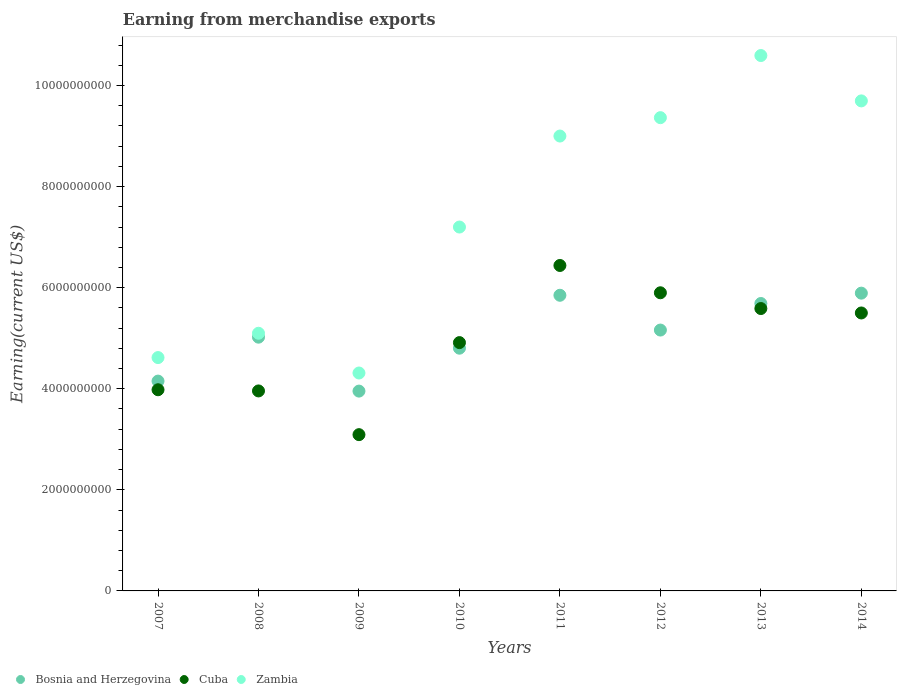What is the amount earned from merchandise exports in Bosnia and Herzegovina in 2009?
Your answer should be compact. 3.95e+09. Across all years, what is the maximum amount earned from merchandise exports in Cuba?
Keep it short and to the point. 6.44e+09. Across all years, what is the minimum amount earned from merchandise exports in Bosnia and Herzegovina?
Offer a very short reply. 3.95e+09. In which year was the amount earned from merchandise exports in Bosnia and Herzegovina minimum?
Give a very brief answer. 2009. What is the total amount earned from merchandise exports in Cuba in the graph?
Give a very brief answer. 3.94e+1. What is the difference between the amount earned from merchandise exports in Bosnia and Herzegovina in 2010 and that in 2012?
Offer a very short reply. -3.59e+08. What is the difference between the amount earned from merchandise exports in Bosnia and Herzegovina in 2013 and the amount earned from merchandise exports in Zambia in 2014?
Your response must be concise. -4.01e+09. What is the average amount earned from merchandise exports in Cuba per year?
Your response must be concise. 4.92e+09. In the year 2007, what is the difference between the amount earned from merchandise exports in Zambia and amount earned from merchandise exports in Bosnia and Herzegovina?
Your answer should be compact. 4.65e+08. What is the ratio of the amount earned from merchandise exports in Zambia in 2011 to that in 2013?
Provide a succinct answer. 0.85. Is the amount earned from merchandise exports in Zambia in 2008 less than that in 2010?
Provide a short and direct response. Yes. What is the difference between the highest and the second highest amount earned from merchandise exports in Bosnia and Herzegovina?
Provide a succinct answer. 4.20e+07. What is the difference between the highest and the lowest amount earned from merchandise exports in Cuba?
Offer a terse response. 3.35e+09. In how many years, is the amount earned from merchandise exports in Zambia greater than the average amount earned from merchandise exports in Zambia taken over all years?
Your answer should be very brief. 4. Is it the case that in every year, the sum of the amount earned from merchandise exports in Cuba and amount earned from merchandise exports in Zambia  is greater than the amount earned from merchandise exports in Bosnia and Herzegovina?
Your answer should be very brief. Yes. Does the amount earned from merchandise exports in Bosnia and Herzegovina monotonically increase over the years?
Your answer should be compact. No. How many years are there in the graph?
Make the answer very short. 8. What is the difference between two consecutive major ticks on the Y-axis?
Make the answer very short. 2.00e+09. Are the values on the major ticks of Y-axis written in scientific E-notation?
Keep it short and to the point. No. Does the graph contain any zero values?
Offer a terse response. No. How many legend labels are there?
Offer a very short reply. 3. What is the title of the graph?
Provide a succinct answer. Earning from merchandise exports. Does "Kiribati" appear as one of the legend labels in the graph?
Provide a short and direct response. No. What is the label or title of the Y-axis?
Offer a terse response. Earning(current US$). What is the Earning(current US$) in Bosnia and Herzegovina in 2007?
Offer a terse response. 4.15e+09. What is the Earning(current US$) of Cuba in 2007?
Your response must be concise. 3.98e+09. What is the Earning(current US$) in Zambia in 2007?
Offer a terse response. 4.62e+09. What is the Earning(current US$) of Bosnia and Herzegovina in 2008?
Offer a very short reply. 5.02e+09. What is the Earning(current US$) in Cuba in 2008?
Offer a terse response. 3.96e+09. What is the Earning(current US$) in Zambia in 2008?
Make the answer very short. 5.10e+09. What is the Earning(current US$) of Bosnia and Herzegovina in 2009?
Offer a terse response. 3.95e+09. What is the Earning(current US$) of Cuba in 2009?
Offer a terse response. 3.09e+09. What is the Earning(current US$) of Zambia in 2009?
Offer a terse response. 4.31e+09. What is the Earning(current US$) of Bosnia and Herzegovina in 2010?
Provide a short and direct response. 4.80e+09. What is the Earning(current US$) of Cuba in 2010?
Provide a succinct answer. 4.91e+09. What is the Earning(current US$) of Zambia in 2010?
Your answer should be compact. 7.20e+09. What is the Earning(current US$) in Bosnia and Herzegovina in 2011?
Provide a succinct answer. 5.85e+09. What is the Earning(current US$) in Cuba in 2011?
Ensure brevity in your answer.  6.44e+09. What is the Earning(current US$) in Zambia in 2011?
Provide a short and direct response. 9.00e+09. What is the Earning(current US$) in Bosnia and Herzegovina in 2012?
Your answer should be very brief. 5.16e+09. What is the Earning(current US$) in Cuba in 2012?
Provide a succinct answer. 5.90e+09. What is the Earning(current US$) in Zambia in 2012?
Provide a succinct answer. 9.36e+09. What is the Earning(current US$) of Bosnia and Herzegovina in 2013?
Offer a very short reply. 5.69e+09. What is the Earning(current US$) of Cuba in 2013?
Offer a very short reply. 5.59e+09. What is the Earning(current US$) of Zambia in 2013?
Keep it short and to the point. 1.06e+1. What is the Earning(current US$) in Bosnia and Herzegovina in 2014?
Give a very brief answer. 5.89e+09. What is the Earning(current US$) of Cuba in 2014?
Keep it short and to the point. 5.50e+09. What is the Earning(current US$) in Zambia in 2014?
Your answer should be very brief. 9.70e+09. Across all years, what is the maximum Earning(current US$) in Bosnia and Herzegovina?
Provide a succinct answer. 5.89e+09. Across all years, what is the maximum Earning(current US$) in Cuba?
Provide a succinct answer. 6.44e+09. Across all years, what is the maximum Earning(current US$) of Zambia?
Your response must be concise. 1.06e+1. Across all years, what is the minimum Earning(current US$) of Bosnia and Herzegovina?
Offer a very short reply. 3.95e+09. Across all years, what is the minimum Earning(current US$) in Cuba?
Make the answer very short. 3.09e+09. Across all years, what is the minimum Earning(current US$) of Zambia?
Offer a very short reply. 4.31e+09. What is the total Earning(current US$) in Bosnia and Herzegovina in the graph?
Your answer should be very brief. 4.05e+1. What is the total Earning(current US$) in Cuba in the graph?
Make the answer very short. 3.94e+1. What is the total Earning(current US$) of Zambia in the graph?
Make the answer very short. 5.99e+1. What is the difference between the Earning(current US$) in Bosnia and Herzegovina in 2007 and that in 2008?
Your response must be concise. -8.69e+08. What is the difference between the Earning(current US$) in Cuba in 2007 and that in 2008?
Offer a terse response. 2.32e+07. What is the difference between the Earning(current US$) in Zambia in 2007 and that in 2008?
Give a very brief answer. -4.81e+08. What is the difference between the Earning(current US$) of Bosnia and Herzegovina in 2007 and that in 2009?
Give a very brief answer. 1.98e+08. What is the difference between the Earning(current US$) in Cuba in 2007 and that in 2009?
Keep it short and to the point. 8.89e+08. What is the difference between the Earning(current US$) of Zambia in 2007 and that in 2009?
Offer a very short reply. 3.05e+08. What is the difference between the Earning(current US$) of Bosnia and Herzegovina in 2007 and that in 2010?
Your response must be concise. -6.51e+08. What is the difference between the Earning(current US$) of Cuba in 2007 and that in 2010?
Offer a very short reply. -9.33e+08. What is the difference between the Earning(current US$) in Zambia in 2007 and that in 2010?
Make the answer very short. -2.58e+09. What is the difference between the Earning(current US$) of Bosnia and Herzegovina in 2007 and that in 2011?
Your answer should be very brief. -1.70e+09. What is the difference between the Earning(current US$) in Cuba in 2007 and that in 2011?
Ensure brevity in your answer.  -2.46e+09. What is the difference between the Earning(current US$) of Zambia in 2007 and that in 2011?
Ensure brevity in your answer.  -4.38e+09. What is the difference between the Earning(current US$) of Bosnia and Herzegovina in 2007 and that in 2012?
Give a very brief answer. -1.01e+09. What is the difference between the Earning(current US$) of Cuba in 2007 and that in 2012?
Your response must be concise. -1.92e+09. What is the difference between the Earning(current US$) in Zambia in 2007 and that in 2012?
Give a very brief answer. -4.75e+09. What is the difference between the Earning(current US$) of Bosnia and Herzegovina in 2007 and that in 2013?
Provide a succinct answer. -1.54e+09. What is the difference between the Earning(current US$) of Cuba in 2007 and that in 2013?
Your answer should be compact. -1.61e+09. What is the difference between the Earning(current US$) in Zambia in 2007 and that in 2013?
Ensure brevity in your answer.  -5.98e+09. What is the difference between the Earning(current US$) of Bosnia and Herzegovina in 2007 and that in 2014?
Your answer should be very brief. -1.74e+09. What is the difference between the Earning(current US$) of Cuba in 2007 and that in 2014?
Give a very brief answer. -1.52e+09. What is the difference between the Earning(current US$) of Zambia in 2007 and that in 2014?
Ensure brevity in your answer.  -5.08e+09. What is the difference between the Earning(current US$) of Bosnia and Herzegovina in 2008 and that in 2009?
Make the answer very short. 1.07e+09. What is the difference between the Earning(current US$) in Cuba in 2008 and that in 2009?
Make the answer very short. 8.65e+08. What is the difference between the Earning(current US$) in Zambia in 2008 and that in 2009?
Ensure brevity in your answer.  7.87e+08. What is the difference between the Earning(current US$) of Bosnia and Herzegovina in 2008 and that in 2010?
Offer a terse response. 2.18e+08. What is the difference between the Earning(current US$) in Cuba in 2008 and that in 2010?
Provide a short and direct response. -9.56e+08. What is the difference between the Earning(current US$) in Zambia in 2008 and that in 2010?
Your answer should be compact. -2.10e+09. What is the difference between the Earning(current US$) in Bosnia and Herzegovina in 2008 and that in 2011?
Make the answer very short. -8.29e+08. What is the difference between the Earning(current US$) of Cuba in 2008 and that in 2011?
Your response must be concise. -2.48e+09. What is the difference between the Earning(current US$) of Zambia in 2008 and that in 2011?
Ensure brevity in your answer.  -3.90e+09. What is the difference between the Earning(current US$) of Bosnia and Herzegovina in 2008 and that in 2012?
Ensure brevity in your answer.  -1.41e+08. What is the difference between the Earning(current US$) in Cuba in 2008 and that in 2012?
Provide a succinct answer. -1.94e+09. What is the difference between the Earning(current US$) in Zambia in 2008 and that in 2012?
Provide a short and direct response. -4.27e+09. What is the difference between the Earning(current US$) in Bosnia and Herzegovina in 2008 and that in 2013?
Offer a terse response. -6.66e+08. What is the difference between the Earning(current US$) of Cuba in 2008 and that in 2013?
Make the answer very short. -1.63e+09. What is the difference between the Earning(current US$) of Zambia in 2008 and that in 2013?
Your answer should be compact. -5.50e+09. What is the difference between the Earning(current US$) in Bosnia and Herzegovina in 2008 and that in 2014?
Your answer should be compact. -8.71e+08. What is the difference between the Earning(current US$) of Cuba in 2008 and that in 2014?
Your answer should be compact. -1.54e+09. What is the difference between the Earning(current US$) in Zambia in 2008 and that in 2014?
Offer a very short reply. -4.60e+09. What is the difference between the Earning(current US$) in Bosnia and Herzegovina in 2009 and that in 2010?
Offer a terse response. -8.49e+08. What is the difference between the Earning(current US$) in Cuba in 2009 and that in 2010?
Provide a short and direct response. -1.82e+09. What is the difference between the Earning(current US$) of Zambia in 2009 and that in 2010?
Ensure brevity in your answer.  -2.89e+09. What is the difference between the Earning(current US$) of Bosnia and Herzegovina in 2009 and that in 2011?
Provide a short and direct response. -1.90e+09. What is the difference between the Earning(current US$) in Cuba in 2009 and that in 2011?
Provide a succinct answer. -3.35e+09. What is the difference between the Earning(current US$) in Zambia in 2009 and that in 2011?
Offer a terse response. -4.69e+09. What is the difference between the Earning(current US$) of Bosnia and Herzegovina in 2009 and that in 2012?
Make the answer very short. -1.21e+09. What is the difference between the Earning(current US$) in Cuba in 2009 and that in 2012?
Your response must be concise. -2.81e+09. What is the difference between the Earning(current US$) of Zambia in 2009 and that in 2012?
Give a very brief answer. -5.05e+09. What is the difference between the Earning(current US$) in Bosnia and Herzegovina in 2009 and that in 2013?
Ensure brevity in your answer.  -1.73e+09. What is the difference between the Earning(current US$) in Cuba in 2009 and that in 2013?
Your answer should be compact. -2.50e+09. What is the difference between the Earning(current US$) of Zambia in 2009 and that in 2013?
Provide a succinct answer. -6.28e+09. What is the difference between the Earning(current US$) in Bosnia and Herzegovina in 2009 and that in 2014?
Offer a terse response. -1.94e+09. What is the difference between the Earning(current US$) of Cuba in 2009 and that in 2014?
Your response must be concise. -2.41e+09. What is the difference between the Earning(current US$) of Zambia in 2009 and that in 2014?
Offer a very short reply. -5.38e+09. What is the difference between the Earning(current US$) of Bosnia and Herzegovina in 2010 and that in 2011?
Your answer should be very brief. -1.05e+09. What is the difference between the Earning(current US$) in Cuba in 2010 and that in 2011?
Offer a terse response. -1.53e+09. What is the difference between the Earning(current US$) of Zambia in 2010 and that in 2011?
Make the answer very short. -1.80e+09. What is the difference between the Earning(current US$) in Bosnia and Herzegovina in 2010 and that in 2012?
Make the answer very short. -3.59e+08. What is the difference between the Earning(current US$) in Cuba in 2010 and that in 2012?
Your answer should be very brief. -9.86e+08. What is the difference between the Earning(current US$) of Zambia in 2010 and that in 2012?
Your answer should be very brief. -2.16e+09. What is the difference between the Earning(current US$) in Bosnia and Herzegovina in 2010 and that in 2013?
Keep it short and to the point. -8.84e+08. What is the difference between the Earning(current US$) in Cuba in 2010 and that in 2013?
Keep it short and to the point. -6.74e+08. What is the difference between the Earning(current US$) in Zambia in 2010 and that in 2013?
Your answer should be compact. -3.39e+09. What is the difference between the Earning(current US$) of Bosnia and Herzegovina in 2010 and that in 2014?
Give a very brief answer. -1.09e+09. What is the difference between the Earning(current US$) of Cuba in 2010 and that in 2014?
Provide a short and direct response. -5.86e+08. What is the difference between the Earning(current US$) in Zambia in 2010 and that in 2014?
Your response must be concise. -2.50e+09. What is the difference between the Earning(current US$) in Bosnia and Herzegovina in 2011 and that in 2012?
Make the answer very short. 6.88e+08. What is the difference between the Earning(current US$) of Cuba in 2011 and that in 2012?
Offer a very short reply. 5.40e+08. What is the difference between the Earning(current US$) of Zambia in 2011 and that in 2012?
Provide a succinct answer. -3.64e+08. What is the difference between the Earning(current US$) of Bosnia and Herzegovina in 2011 and that in 2013?
Give a very brief answer. 1.63e+08. What is the difference between the Earning(current US$) in Cuba in 2011 and that in 2013?
Offer a terse response. 8.52e+08. What is the difference between the Earning(current US$) in Zambia in 2011 and that in 2013?
Provide a succinct answer. -1.59e+09. What is the difference between the Earning(current US$) in Bosnia and Herzegovina in 2011 and that in 2014?
Provide a succinct answer. -4.20e+07. What is the difference between the Earning(current US$) in Cuba in 2011 and that in 2014?
Provide a succinct answer. 9.40e+08. What is the difference between the Earning(current US$) in Zambia in 2011 and that in 2014?
Your response must be concise. -6.95e+08. What is the difference between the Earning(current US$) in Bosnia and Herzegovina in 2012 and that in 2013?
Make the answer very short. -5.26e+08. What is the difference between the Earning(current US$) in Cuba in 2012 and that in 2013?
Offer a very short reply. 3.12e+08. What is the difference between the Earning(current US$) of Zambia in 2012 and that in 2013?
Ensure brevity in your answer.  -1.23e+09. What is the difference between the Earning(current US$) in Bosnia and Herzegovina in 2012 and that in 2014?
Your response must be concise. -7.30e+08. What is the difference between the Earning(current US$) in Cuba in 2012 and that in 2014?
Offer a very short reply. 4.00e+08. What is the difference between the Earning(current US$) in Zambia in 2012 and that in 2014?
Give a very brief answer. -3.32e+08. What is the difference between the Earning(current US$) in Bosnia and Herzegovina in 2013 and that in 2014?
Keep it short and to the point. -2.05e+08. What is the difference between the Earning(current US$) in Cuba in 2013 and that in 2014?
Keep it short and to the point. 8.77e+07. What is the difference between the Earning(current US$) of Zambia in 2013 and that in 2014?
Keep it short and to the point. 8.98e+08. What is the difference between the Earning(current US$) in Bosnia and Herzegovina in 2007 and the Earning(current US$) in Cuba in 2008?
Keep it short and to the point. 1.95e+08. What is the difference between the Earning(current US$) in Bosnia and Herzegovina in 2007 and the Earning(current US$) in Zambia in 2008?
Offer a very short reply. -9.47e+08. What is the difference between the Earning(current US$) in Cuba in 2007 and the Earning(current US$) in Zambia in 2008?
Offer a terse response. -1.12e+09. What is the difference between the Earning(current US$) of Bosnia and Herzegovina in 2007 and the Earning(current US$) of Cuba in 2009?
Offer a very short reply. 1.06e+09. What is the difference between the Earning(current US$) in Bosnia and Herzegovina in 2007 and the Earning(current US$) in Zambia in 2009?
Your answer should be compact. -1.60e+08. What is the difference between the Earning(current US$) of Cuba in 2007 and the Earning(current US$) of Zambia in 2009?
Your response must be concise. -3.31e+08. What is the difference between the Earning(current US$) of Bosnia and Herzegovina in 2007 and the Earning(current US$) of Cuba in 2010?
Offer a very short reply. -7.62e+08. What is the difference between the Earning(current US$) of Bosnia and Herzegovina in 2007 and the Earning(current US$) of Zambia in 2010?
Your response must be concise. -3.05e+09. What is the difference between the Earning(current US$) of Cuba in 2007 and the Earning(current US$) of Zambia in 2010?
Provide a short and direct response. -3.22e+09. What is the difference between the Earning(current US$) of Bosnia and Herzegovina in 2007 and the Earning(current US$) of Cuba in 2011?
Your answer should be very brief. -2.29e+09. What is the difference between the Earning(current US$) of Bosnia and Herzegovina in 2007 and the Earning(current US$) of Zambia in 2011?
Provide a short and direct response. -4.85e+09. What is the difference between the Earning(current US$) in Cuba in 2007 and the Earning(current US$) in Zambia in 2011?
Your answer should be compact. -5.02e+09. What is the difference between the Earning(current US$) of Bosnia and Herzegovina in 2007 and the Earning(current US$) of Cuba in 2012?
Keep it short and to the point. -1.75e+09. What is the difference between the Earning(current US$) of Bosnia and Herzegovina in 2007 and the Earning(current US$) of Zambia in 2012?
Keep it short and to the point. -5.21e+09. What is the difference between the Earning(current US$) in Cuba in 2007 and the Earning(current US$) in Zambia in 2012?
Your answer should be very brief. -5.38e+09. What is the difference between the Earning(current US$) of Bosnia and Herzegovina in 2007 and the Earning(current US$) of Cuba in 2013?
Provide a succinct answer. -1.44e+09. What is the difference between the Earning(current US$) of Bosnia and Herzegovina in 2007 and the Earning(current US$) of Zambia in 2013?
Offer a very short reply. -6.44e+09. What is the difference between the Earning(current US$) in Cuba in 2007 and the Earning(current US$) in Zambia in 2013?
Make the answer very short. -6.61e+09. What is the difference between the Earning(current US$) in Bosnia and Herzegovina in 2007 and the Earning(current US$) in Cuba in 2014?
Your answer should be very brief. -1.35e+09. What is the difference between the Earning(current US$) of Bosnia and Herzegovina in 2007 and the Earning(current US$) of Zambia in 2014?
Your answer should be very brief. -5.54e+09. What is the difference between the Earning(current US$) in Cuba in 2007 and the Earning(current US$) in Zambia in 2014?
Make the answer very short. -5.72e+09. What is the difference between the Earning(current US$) of Bosnia and Herzegovina in 2008 and the Earning(current US$) of Cuba in 2009?
Give a very brief answer. 1.93e+09. What is the difference between the Earning(current US$) in Bosnia and Herzegovina in 2008 and the Earning(current US$) in Zambia in 2009?
Offer a very short reply. 7.09e+08. What is the difference between the Earning(current US$) of Cuba in 2008 and the Earning(current US$) of Zambia in 2009?
Your answer should be very brief. -3.55e+08. What is the difference between the Earning(current US$) of Bosnia and Herzegovina in 2008 and the Earning(current US$) of Cuba in 2010?
Provide a short and direct response. 1.07e+08. What is the difference between the Earning(current US$) in Bosnia and Herzegovina in 2008 and the Earning(current US$) in Zambia in 2010?
Keep it short and to the point. -2.18e+09. What is the difference between the Earning(current US$) of Cuba in 2008 and the Earning(current US$) of Zambia in 2010?
Give a very brief answer. -3.24e+09. What is the difference between the Earning(current US$) of Bosnia and Herzegovina in 2008 and the Earning(current US$) of Cuba in 2011?
Make the answer very short. -1.42e+09. What is the difference between the Earning(current US$) in Bosnia and Herzegovina in 2008 and the Earning(current US$) in Zambia in 2011?
Your answer should be compact. -3.98e+09. What is the difference between the Earning(current US$) in Cuba in 2008 and the Earning(current US$) in Zambia in 2011?
Your answer should be compact. -5.04e+09. What is the difference between the Earning(current US$) of Bosnia and Herzegovina in 2008 and the Earning(current US$) of Cuba in 2012?
Your response must be concise. -8.78e+08. What is the difference between the Earning(current US$) in Bosnia and Herzegovina in 2008 and the Earning(current US$) in Zambia in 2012?
Give a very brief answer. -4.34e+09. What is the difference between the Earning(current US$) in Cuba in 2008 and the Earning(current US$) in Zambia in 2012?
Provide a succinct answer. -5.41e+09. What is the difference between the Earning(current US$) in Bosnia and Herzegovina in 2008 and the Earning(current US$) in Cuba in 2013?
Your answer should be compact. -5.67e+08. What is the difference between the Earning(current US$) of Bosnia and Herzegovina in 2008 and the Earning(current US$) of Zambia in 2013?
Your answer should be very brief. -5.57e+09. What is the difference between the Earning(current US$) in Cuba in 2008 and the Earning(current US$) in Zambia in 2013?
Your response must be concise. -6.64e+09. What is the difference between the Earning(current US$) of Bosnia and Herzegovina in 2008 and the Earning(current US$) of Cuba in 2014?
Your answer should be compact. -4.79e+08. What is the difference between the Earning(current US$) of Bosnia and Herzegovina in 2008 and the Earning(current US$) of Zambia in 2014?
Give a very brief answer. -4.68e+09. What is the difference between the Earning(current US$) of Cuba in 2008 and the Earning(current US$) of Zambia in 2014?
Offer a very short reply. -5.74e+09. What is the difference between the Earning(current US$) of Bosnia and Herzegovina in 2009 and the Earning(current US$) of Cuba in 2010?
Provide a succinct answer. -9.60e+08. What is the difference between the Earning(current US$) of Bosnia and Herzegovina in 2009 and the Earning(current US$) of Zambia in 2010?
Your answer should be compact. -3.25e+09. What is the difference between the Earning(current US$) in Cuba in 2009 and the Earning(current US$) in Zambia in 2010?
Your response must be concise. -4.11e+09. What is the difference between the Earning(current US$) in Bosnia and Herzegovina in 2009 and the Earning(current US$) in Cuba in 2011?
Ensure brevity in your answer.  -2.49e+09. What is the difference between the Earning(current US$) of Bosnia and Herzegovina in 2009 and the Earning(current US$) of Zambia in 2011?
Your response must be concise. -5.05e+09. What is the difference between the Earning(current US$) of Cuba in 2009 and the Earning(current US$) of Zambia in 2011?
Your answer should be very brief. -5.91e+09. What is the difference between the Earning(current US$) of Bosnia and Herzegovina in 2009 and the Earning(current US$) of Cuba in 2012?
Your response must be concise. -1.95e+09. What is the difference between the Earning(current US$) in Bosnia and Herzegovina in 2009 and the Earning(current US$) in Zambia in 2012?
Your response must be concise. -5.41e+09. What is the difference between the Earning(current US$) in Cuba in 2009 and the Earning(current US$) in Zambia in 2012?
Your response must be concise. -6.27e+09. What is the difference between the Earning(current US$) of Bosnia and Herzegovina in 2009 and the Earning(current US$) of Cuba in 2013?
Your answer should be very brief. -1.63e+09. What is the difference between the Earning(current US$) in Bosnia and Herzegovina in 2009 and the Earning(current US$) in Zambia in 2013?
Your answer should be very brief. -6.64e+09. What is the difference between the Earning(current US$) of Cuba in 2009 and the Earning(current US$) of Zambia in 2013?
Ensure brevity in your answer.  -7.50e+09. What is the difference between the Earning(current US$) of Bosnia and Herzegovina in 2009 and the Earning(current US$) of Cuba in 2014?
Provide a succinct answer. -1.55e+09. What is the difference between the Earning(current US$) of Bosnia and Herzegovina in 2009 and the Earning(current US$) of Zambia in 2014?
Offer a terse response. -5.74e+09. What is the difference between the Earning(current US$) of Cuba in 2009 and the Earning(current US$) of Zambia in 2014?
Offer a terse response. -6.60e+09. What is the difference between the Earning(current US$) of Bosnia and Herzegovina in 2010 and the Earning(current US$) of Cuba in 2011?
Offer a very short reply. -1.64e+09. What is the difference between the Earning(current US$) of Bosnia and Herzegovina in 2010 and the Earning(current US$) of Zambia in 2011?
Make the answer very short. -4.20e+09. What is the difference between the Earning(current US$) in Cuba in 2010 and the Earning(current US$) in Zambia in 2011?
Provide a short and direct response. -4.09e+09. What is the difference between the Earning(current US$) in Bosnia and Herzegovina in 2010 and the Earning(current US$) in Cuba in 2012?
Ensure brevity in your answer.  -1.10e+09. What is the difference between the Earning(current US$) of Bosnia and Herzegovina in 2010 and the Earning(current US$) of Zambia in 2012?
Provide a short and direct response. -4.56e+09. What is the difference between the Earning(current US$) of Cuba in 2010 and the Earning(current US$) of Zambia in 2012?
Offer a terse response. -4.45e+09. What is the difference between the Earning(current US$) of Bosnia and Herzegovina in 2010 and the Earning(current US$) of Cuba in 2013?
Ensure brevity in your answer.  -7.85e+08. What is the difference between the Earning(current US$) of Bosnia and Herzegovina in 2010 and the Earning(current US$) of Zambia in 2013?
Keep it short and to the point. -5.79e+09. What is the difference between the Earning(current US$) in Cuba in 2010 and the Earning(current US$) in Zambia in 2013?
Offer a very short reply. -5.68e+09. What is the difference between the Earning(current US$) of Bosnia and Herzegovina in 2010 and the Earning(current US$) of Cuba in 2014?
Your response must be concise. -6.97e+08. What is the difference between the Earning(current US$) in Bosnia and Herzegovina in 2010 and the Earning(current US$) in Zambia in 2014?
Your answer should be very brief. -4.89e+09. What is the difference between the Earning(current US$) in Cuba in 2010 and the Earning(current US$) in Zambia in 2014?
Your response must be concise. -4.78e+09. What is the difference between the Earning(current US$) of Bosnia and Herzegovina in 2011 and the Earning(current US$) of Cuba in 2012?
Make the answer very short. -4.94e+07. What is the difference between the Earning(current US$) in Bosnia and Herzegovina in 2011 and the Earning(current US$) in Zambia in 2012?
Your response must be concise. -3.51e+09. What is the difference between the Earning(current US$) in Cuba in 2011 and the Earning(current US$) in Zambia in 2012?
Offer a very short reply. -2.92e+09. What is the difference between the Earning(current US$) in Bosnia and Herzegovina in 2011 and the Earning(current US$) in Cuba in 2013?
Keep it short and to the point. 2.62e+08. What is the difference between the Earning(current US$) of Bosnia and Herzegovina in 2011 and the Earning(current US$) of Zambia in 2013?
Provide a succinct answer. -4.74e+09. What is the difference between the Earning(current US$) in Cuba in 2011 and the Earning(current US$) in Zambia in 2013?
Your answer should be compact. -4.15e+09. What is the difference between the Earning(current US$) in Bosnia and Herzegovina in 2011 and the Earning(current US$) in Cuba in 2014?
Give a very brief answer. 3.50e+08. What is the difference between the Earning(current US$) of Bosnia and Herzegovina in 2011 and the Earning(current US$) of Zambia in 2014?
Provide a succinct answer. -3.85e+09. What is the difference between the Earning(current US$) of Cuba in 2011 and the Earning(current US$) of Zambia in 2014?
Ensure brevity in your answer.  -3.26e+09. What is the difference between the Earning(current US$) of Bosnia and Herzegovina in 2012 and the Earning(current US$) of Cuba in 2013?
Provide a short and direct response. -4.26e+08. What is the difference between the Earning(current US$) in Bosnia and Herzegovina in 2012 and the Earning(current US$) in Zambia in 2013?
Offer a very short reply. -5.43e+09. What is the difference between the Earning(current US$) of Cuba in 2012 and the Earning(current US$) of Zambia in 2013?
Keep it short and to the point. -4.69e+09. What is the difference between the Earning(current US$) in Bosnia and Herzegovina in 2012 and the Earning(current US$) in Cuba in 2014?
Provide a short and direct response. -3.38e+08. What is the difference between the Earning(current US$) of Bosnia and Herzegovina in 2012 and the Earning(current US$) of Zambia in 2014?
Make the answer very short. -4.53e+09. What is the difference between the Earning(current US$) of Cuba in 2012 and the Earning(current US$) of Zambia in 2014?
Offer a terse response. -3.80e+09. What is the difference between the Earning(current US$) in Bosnia and Herzegovina in 2013 and the Earning(current US$) in Cuba in 2014?
Give a very brief answer. 1.87e+08. What is the difference between the Earning(current US$) of Bosnia and Herzegovina in 2013 and the Earning(current US$) of Zambia in 2014?
Keep it short and to the point. -4.01e+09. What is the difference between the Earning(current US$) in Cuba in 2013 and the Earning(current US$) in Zambia in 2014?
Ensure brevity in your answer.  -4.11e+09. What is the average Earning(current US$) of Bosnia and Herzegovina per year?
Offer a very short reply. 5.07e+09. What is the average Earning(current US$) of Cuba per year?
Your answer should be very brief. 4.92e+09. What is the average Earning(current US$) in Zambia per year?
Your answer should be very brief. 7.49e+09. In the year 2007, what is the difference between the Earning(current US$) in Bosnia and Herzegovina and Earning(current US$) in Cuba?
Ensure brevity in your answer.  1.71e+08. In the year 2007, what is the difference between the Earning(current US$) in Bosnia and Herzegovina and Earning(current US$) in Zambia?
Make the answer very short. -4.65e+08. In the year 2007, what is the difference between the Earning(current US$) of Cuba and Earning(current US$) of Zambia?
Provide a short and direct response. -6.37e+08. In the year 2008, what is the difference between the Earning(current US$) of Bosnia and Herzegovina and Earning(current US$) of Cuba?
Make the answer very short. 1.06e+09. In the year 2008, what is the difference between the Earning(current US$) in Bosnia and Herzegovina and Earning(current US$) in Zambia?
Your response must be concise. -7.76e+07. In the year 2008, what is the difference between the Earning(current US$) of Cuba and Earning(current US$) of Zambia?
Give a very brief answer. -1.14e+09. In the year 2009, what is the difference between the Earning(current US$) in Bosnia and Herzegovina and Earning(current US$) in Cuba?
Ensure brevity in your answer.  8.62e+08. In the year 2009, what is the difference between the Earning(current US$) in Bosnia and Herzegovina and Earning(current US$) in Zambia?
Give a very brief answer. -3.58e+08. In the year 2009, what is the difference between the Earning(current US$) in Cuba and Earning(current US$) in Zambia?
Ensure brevity in your answer.  -1.22e+09. In the year 2010, what is the difference between the Earning(current US$) in Bosnia and Herzegovina and Earning(current US$) in Cuba?
Offer a very short reply. -1.10e+08. In the year 2010, what is the difference between the Earning(current US$) of Bosnia and Herzegovina and Earning(current US$) of Zambia?
Give a very brief answer. -2.40e+09. In the year 2010, what is the difference between the Earning(current US$) of Cuba and Earning(current US$) of Zambia?
Provide a succinct answer. -2.29e+09. In the year 2011, what is the difference between the Earning(current US$) of Bosnia and Herzegovina and Earning(current US$) of Cuba?
Your response must be concise. -5.90e+08. In the year 2011, what is the difference between the Earning(current US$) of Bosnia and Herzegovina and Earning(current US$) of Zambia?
Offer a terse response. -3.15e+09. In the year 2011, what is the difference between the Earning(current US$) of Cuba and Earning(current US$) of Zambia?
Offer a very short reply. -2.56e+09. In the year 2012, what is the difference between the Earning(current US$) of Bosnia and Herzegovina and Earning(current US$) of Cuba?
Your response must be concise. -7.38e+08. In the year 2012, what is the difference between the Earning(current US$) in Bosnia and Herzegovina and Earning(current US$) in Zambia?
Offer a terse response. -4.20e+09. In the year 2012, what is the difference between the Earning(current US$) in Cuba and Earning(current US$) in Zambia?
Offer a very short reply. -3.47e+09. In the year 2013, what is the difference between the Earning(current US$) of Bosnia and Herzegovina and Earning(current US$) of Cuba?
Provide a succinct answer. 9.96e+07. In the year 2013, what is the difference between the Earning(current US$) of Bosnia and Herzegovina and Earning(current US$) of Zambia?
Offer a very short reply. -4.91e+09. In the year 2013, what is the difference between the Earning(current US$) of Cuba and Earning(current US$) of Zambia?
Offer a very short reply. -5.01e+09. In the year 2014, what is the difference between the Earning(current US$) of Bosnia and Herzegovina and Earning(current US$) of Cuba?
Your answer should be compact. 3.92e+08. In the year 2014, what is the difference between the Earning(current US$) of Bosnia and Herzegovina and Earning(current US$) of Zambia?
Your response must be concise. -3.80e+09. In the year 2014, what is the difference between the Earning(current US$) of Cuba and Earning(current US$) of Zambia?
Ensure brevity in your answer.  -4.20e+09. What is the ratio of the Earning(current US$) of Bosnia and Herzegovina in 2007 to that in 2008?
Offer a very short reply. 0.83. What is the ratio of the Earning(current US$) of Cuba in 2007 to that in 2008?
Make the answer very short. 1.01. What is the ratio of the Earning(current US$) of Zambia in 2007 to that in 2008?
Offer a terse response. 0.91. What is the ratio of the Earning(current US$) in Bosnia and Herzegovina in 2007 to that in 2009?
Your answer should be very brief. 1.05. What is the ratio of the Earning(current US$) in Cuba in 2007 to that in 2009?
Ensure brevity in your answer.  1.29. What is the ratio of the Earning(current US$) of Zambia in 2007 to that in 2009?
Ensure brevity in your answer.  1.07. What is the ratio of the Earning(current US$) of Bosnia and Herzegovina in 2007 to that in 2010?
Offer a very short reply. 0.86. What is the ratio of the Earning(current US$) in Cuba in 2007 to that in 2010?
Offer a very short reply. 0.81. What is the ratio of the Earning(current US$) in Zambia in 2007 to that in 2010?
Your response must be concise. 0.64. What is the ratio of the Earning(current US$) in Bosnia and Herzegovina in 2007 to that in 2011?
Your response must be concise. 0.71. What is the ratio of the Earning(current US$) of Cuba in 2007 to that in 2011?
Your answer should be very brief. 0.62. What is the ratio of the Earning(current US$) in Zambia in 2007 to that in 2011?
Make the answer very short. 0.51. What is the ratio of the Earning(current US$) in Bosnia and Herzegovina in 2007 to that in 2012?
Your answer should be very brief. 0.8. What is the ratio of the Earning(current US$) of Cuba in 2007 to that in 2012?
Provide a short and direct response. 0.67. What is the ratio of the Earning(current US$) in Zambia in 2007 to that in 2012?
Offer a terse response. 0.49. What is the ratio of the Earning(current US$) in Bosnia and Herzegovina in 2007 to that in 2013?
Provide a succinct answer. 0.73. What is the ratio of the Earning(current US$) of Cuba in 2007 to that in 2013?
Give a very brief answer. 0.71. What is the ratio of the Earning(current US$) of Zambia in 2007 to that in 2013?
Your answer should be very brief. 0.44. What is the ratio of the Earning(current US$) in Bosnia and Herzegovina in 2007 to that in 2014?
Give a very brief answer. 0.7. What is the ratio of the Earning(current US$) of Cuba in 2007 to that in 2014?
Offer a very short reply. 0.72. What is the ratio of the Earning(current US$) in Zambia in 2007 to that in 2014?
Your answer should be very brief. 0.48. What is the ratio of the Earning(current US$) of Bosnia and Herzegovina in 2008 to that in 2009?
Ensure brevity in your answer.  1.27. What is the ratio of the Earning(current US$) of Cuba in 2008 to that in 2009?
Give a very brief answer. 1.28. What is the ratio of the Earning(current US$) in Zambia in 2008 to that in 2009?
Keep it short and to the point. 1.18. What is the ratio of the Earning(current US$) in Bosnia and Herzegovina in 2008 to that in 2010?
Provide a succinct answer. 1.05. What is the ratio of the Earning(current US$) in Cuba in 2008 to that in 2010?
Offer a terse response. 0.81. What is the ratio of the Earning(current US$) in Zambia in 2008 to that in 2010?
Ensure brevity in your answer.  0.71. What is the ratio of the Earning(current US$) in Bosnia and Herzegovina in 2008 to that in 2011?
Make the answer very short. 0.86. What is the ratio of the Earning(current US$) of Cuba in 2008 to that in 2011?
Give a very brief answer. 0.61. What is the ratio of the Earning(current US$) in Zambia in 2008 to that in 2011?
Make the answer very short. 0.57. What is the ratio of the Earning(current US$) of Bosnia and Herzegovina in 2008 to that in 2012?
Your response must be concise. 0.97. What is the ratio of the Earning(current US$) of Cuba in 2008 to that in 2012?
Provide a succinct answer. 0.67. What is the ratio of the Earning(current US$) in Zambia in 2008 to that in 2012?
Your response must be concise. 0.54. What is the ratio of the Earning(current US$) in Bosnia and Herzegovina in 2008 to that in 2013?
Your answer should be very brief. 0.88. What is the ratio of the Earning(current US$) in Cuba in 2008 to that in 2013?
Your answer should be very brief. 0.71. What is the ratio of the Earning(current US$) in Zambia in 2008 to that in 2013?
Provide a succinct answer. 0.48. What is the ratio of the Earning(current US$) in Bosnia and Herzegovina in 2008 to that in 2014?
Ensure brevity in your answer.  0.85. What is the ratio of the Earning(current US$) of Cuba in 2008 to that in 2014?
Your answer should be compact. 0.72. What is the ratio of the Earning(current US$) of Zambia in 2008 to that in 2014?
Your response must be concise. 0.53. What is the ratio of the Earning(current US$) in Bosnia and Herzegovina in 2009 to that in 2010?
Offer a very short reply. 0.82. What is the ratio of the Earning(current US$) in Cuba in 2009 to that in 2010?
Offer a very short reply. 0.63. What is the ratio of the Earning(current US$) of Zambia in 2009 to that in 2010?
Ensure brevity in your answer.  0.6. What is the ratio of the Earning(current US$) in Bosnia and Herzegovina in 2009 to that in 2011?
Provide a short and direct response. 0.68. What is the ratio of the Earning(current US$) in Cuba in 2009 to that in 2011?
Ensure brevity in your answer.  0.48. What is the ratio of the Earning(current US$) in Zambia in 2009 to that in 2011?
Provide a short and direct response. 0.48. What is the ratio of the Earning(current US$) in Bosnia and Herzegovina in 2009 to that in 2012?
Offer a terse response. 0.77. What is the ratio of the Earning(current US$) in Cuba in 2009 to that in 2012?
Offer a very short reply. 0.52. What is the ratio of the Earning(current US$) of Zambia in 2009 to that in 2012?
Keep it short and to the point. 0.46. What is the ratio of the Earning(current US$) in Bosnia and Herzegovina in 2009 to that in 2013?
Make the answer very short. 0.7. What is the ratio of the Earning(current US$) in Cuba in 2009 to that in 2013?
Your response must be concise. 0.55. What is the ratio of the Earning(current US$) in Zambia in 2009 to that in 2013?
Your answer should be compact. 0.41. What is the ratio of the Earning(current US$) in Bosnia and Herzegovina in 2009 to that in 2014?
Offer a terse response. 0.67. What is the ratio of the Earning(current US$) in Cuba in 2009 to that in 2014?
Make the answer very short. 0.56. What is the ratio of the Earning(current US$) of Zambia in 2009 to that in 2014?
Give a very brief answer. 0.44. What is the ratio of the Earning(current US$) in Bosnia and Herzegovina in 2010 to that in 2011?
Keep it short and to the point. 0.82. What is the ratio of the Earning(current US$) in Cuba in 2010 to that in 2011?
Your response must be concise. 0.76. What is the ratio of the Earning(current US$) in Zambia in 2010 to that in 2011?
Your response must be concise. 0.8. What is the ratio of the Earning(current US$) of Bosnia and Herzegovina in 2010 to that in 2012?
Offer a terse response. 0.93. What is the ratio of the Earning(current US$) in Cuba in 2010 to that in 2012?
Give a very brief answer. 0.83. What is the ratio of the Earning(current US$) in Zambia in 2010 to that in 2012?
Your answer should be very brief. 0.77. What is the ratio of the Earning(current US$) in Bosnia and Herzegovina in 2010 to that in 2013?
Give a very brief answer. 0.84. What is the ratio of the Earning(current US$) in Cuba in 2010 to that in 2013?
Provide a succinct answer. 0.88. What is the ratio of the Earning(current US$) of Zambia in 2010 to that in 2013?
Make the answer very short. 0.68. What is the ratio of the Earning(current US$) of Bosnia and Herzegovina in 2010 to that in 2014?
Your answer should be compact. 0.82. What is the ratio of the Earning(current US$) of Cuba in 2010 to that in 2014?
Your response must be concise. 0.89. What is the ratio of the Earning(current US$) in Zambia in 2010 to that in 2014?
Keep it short and to the point. 0.74. What is the ratio of the Earning(current US$) in Bosnia and Herzegovina in 2011 to that in 2012?
Keep it short and to the point. 1.13. What is the ratio of the Earning(current US$) of Cuba in 2011 to that in 2012?
Make the answer very short. 1.09. What is the ratio of the Earning(current US$) of Zambia in 2011 to that in 2012?
Your response must be concise. 0.96. What is the ratio of the Earning(current US$) in Bosnia and Herzegovina in 2011 to that in 2013?
Provide a succinct answer. 1.03. What is the ratio of the Earning(current US$) in Cuba in 2011 to that in 2013?
Give a very brief answer. 1.15. What is the ratio of the Earning(current US$) of Zambia in 2011 to that in 2013?
Give a very brief answer. 0.85. What is the ratio of the Earning(current US$) of Bosnia and Herzegovina in 2011 to that in 2014?
Provide a short and direct response. 0.99. What is the ratio of the Earning(current US$) in Cuba in 2011 to that in 2014?
Your response must be concise. 1.17. What is the ratio of the Earning(current US$) of Zambia in 2011 to that in 2014?
Your response must be concise. 0.93. What is the ratio of the Earning(current US$) of Bosnia and Herzegovina in 2012 to that in 2013?
Ensure brevity in your answer.  0.91. What is the ratio of the Earning(current US$) in Cuba in 2012 to that in 2013?
Offer a terse response. 1.06. What is the ratio of the Earning(current US$) in Zambia in 2012 to that in 2013?
Offer a terse response. 0.88. What is the ratio of the Earning(current US$) of Bosnia and Herzegovina in 2012 to that in 2014?
Ensure brevity in your answer.  0.88. What is the ratio of the Earning(current US$) of Cuba in 2012 to that in 2014?
Give a very brief answer. 1.07. What is the ratio of the Earning(current US$) in Zambia in 2012 to that in 2014?
Provide a succinct answer. 0.97. What is the ratio of the Earning(current US$) of Bosnia and Herzegovina in 2013 to that in 2014?
Provide a succinct answer. 0.97. What is the ratio of the Earning(current US$) in Cuba in 2013 to that in 2014?
Give a very brief answer. 1.02. What is the ratio of the Earning(current US$) in Zambia in 2013 to that in 2014?
Offer a terse response. 1.09. What is the difference between the highest and the second highest Earning(current US$) of Bosnia and Herzegovina?
Ensure brevity in your answer.  4.20e+07. What is the difference between the highest and the second highest Earning(current US$) in Cuba?
Make the answer very short. 5.40e+08. What is the difference between the highest and the second highest Earning(current US$) in Zambia?
Your answer should be compact. 8.98e+08. What is the difference between the highest and the lowest Earning(current US$) in Bosnia and Herzegovina?
Your answer should be compact. 1.94e+09. What is the difference between the highest and the lowest Earning(current US$) of Cuba?
Your answer should be compact. 3.35e+09. What is the difference between the highest and the lowest Earning(current US$) of Zambia?
Ensure brevity in your answer.  6.28e+09. 